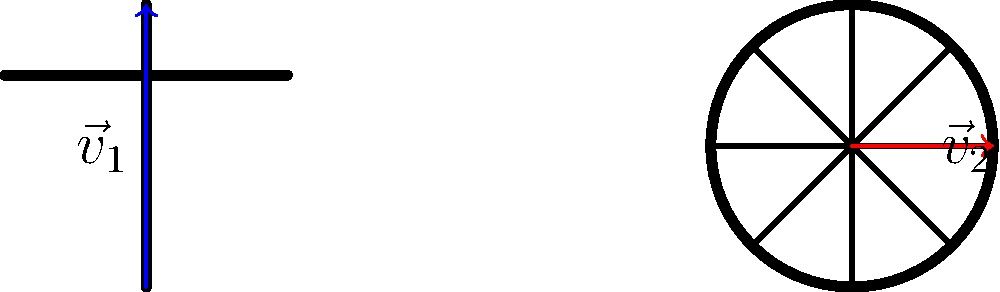In the diagram, the Christian cross and Buddhist dharma wheel are represented by vectors $\vec{v}_1$ and $\vec{v}_2$ respectively. If $\vec{v}_1 = \begin{pmatrix} 0 \\ 2 \end{pmatrix}$ and $\vec{v}_2 = \begin{pmatrix} 1 \\ 0 \end{pmatrix}$, what is the dot product $\vec{v}_1 \cdot \vec{v}_2$? To find the dot product of two vectors, we multiply their corresponding components and sum the results. Let's approach this step-by-step:

1. Given vectors:
   $\vec{v}_1 = \begin{pmatrix} 0 \\ 2 \end{pmatrix}$ and $\vec{v}_2 = \begin{pmatrix} 1 \\ 0 \end{pmatrix}$

2. The dot product formula:
   $\vec{v}_1 \cdot \vec{v}_2 = (x_1 \times x_2) + (y_1 \times y_2)$

3. Substituting the values:
   $\vec{v}_1 \cdot \vec{v}_2 = (0 \times 1) + (2 \times 0)$

4. Calculating:
   $\vec{v}_1 \cdot \vec{v}_2 = 0 + 0 = 0$

5. Interpretation:
   The dot product being zero indicates that these vectors are perpendicular, symbolizing the distinct yet complementary nature of Christian and Buddhist symbolism in this context.
Answer: 0 